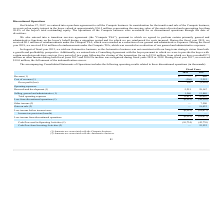According to Macom Technology's financial document, When did the company enter into purchase agreement to sell the Compute business? According to the financial document, October 27, 2017. The relevant text states: "On October 27, 2017, we entered into a purchase agreement to sell the Compute business. In consideration for the transf..." Also, What was the Revenue in 2018 and 2017 respectively? The document shows two values: $— and $660 (in thousands). From the document: "Revenue (1) $ — $ 660 Revenue (1) $ — $ 660..." Also, What was the amount of reimbursements under the Compute TSA in 2019? According to the financial document, $0.1 million. The relevant text states: "incurred. During the fiscal year 2019, we received $0.1 million of reimbursements under the Compute TSA, which was recorded as a reduction of our general and admini..." Additionally, In which year was Cost of revenue negative? According to the financial document, 2018. The relevant text states: "2018 2017..." Also, can you calculate: What was the average Research and development for 2017 and 2018? To answer this question, I need to perform calculations using the financial data. The calculation is: (5,251 + 29,167) / 2, which equals 17209 (in thousands). This is based on the information: "Research and development (1) 5,251 29,167 Research and development (1) 5,251 29,167..." The key data points involved are: 29,167, 5,251. Also, can you calculate: What was the change in the Selling, general and administrative expense from 2017 to 2018? Based on the calculation: 1,560 - 13,840, the result is -12280 (in thousands). This is based on the information: "Selling, general and administrative (1) 1,560 13,840 Selling, general and administrative (1) 1,560 13,840..." The key data points involved are: 1,560, 13,840. 